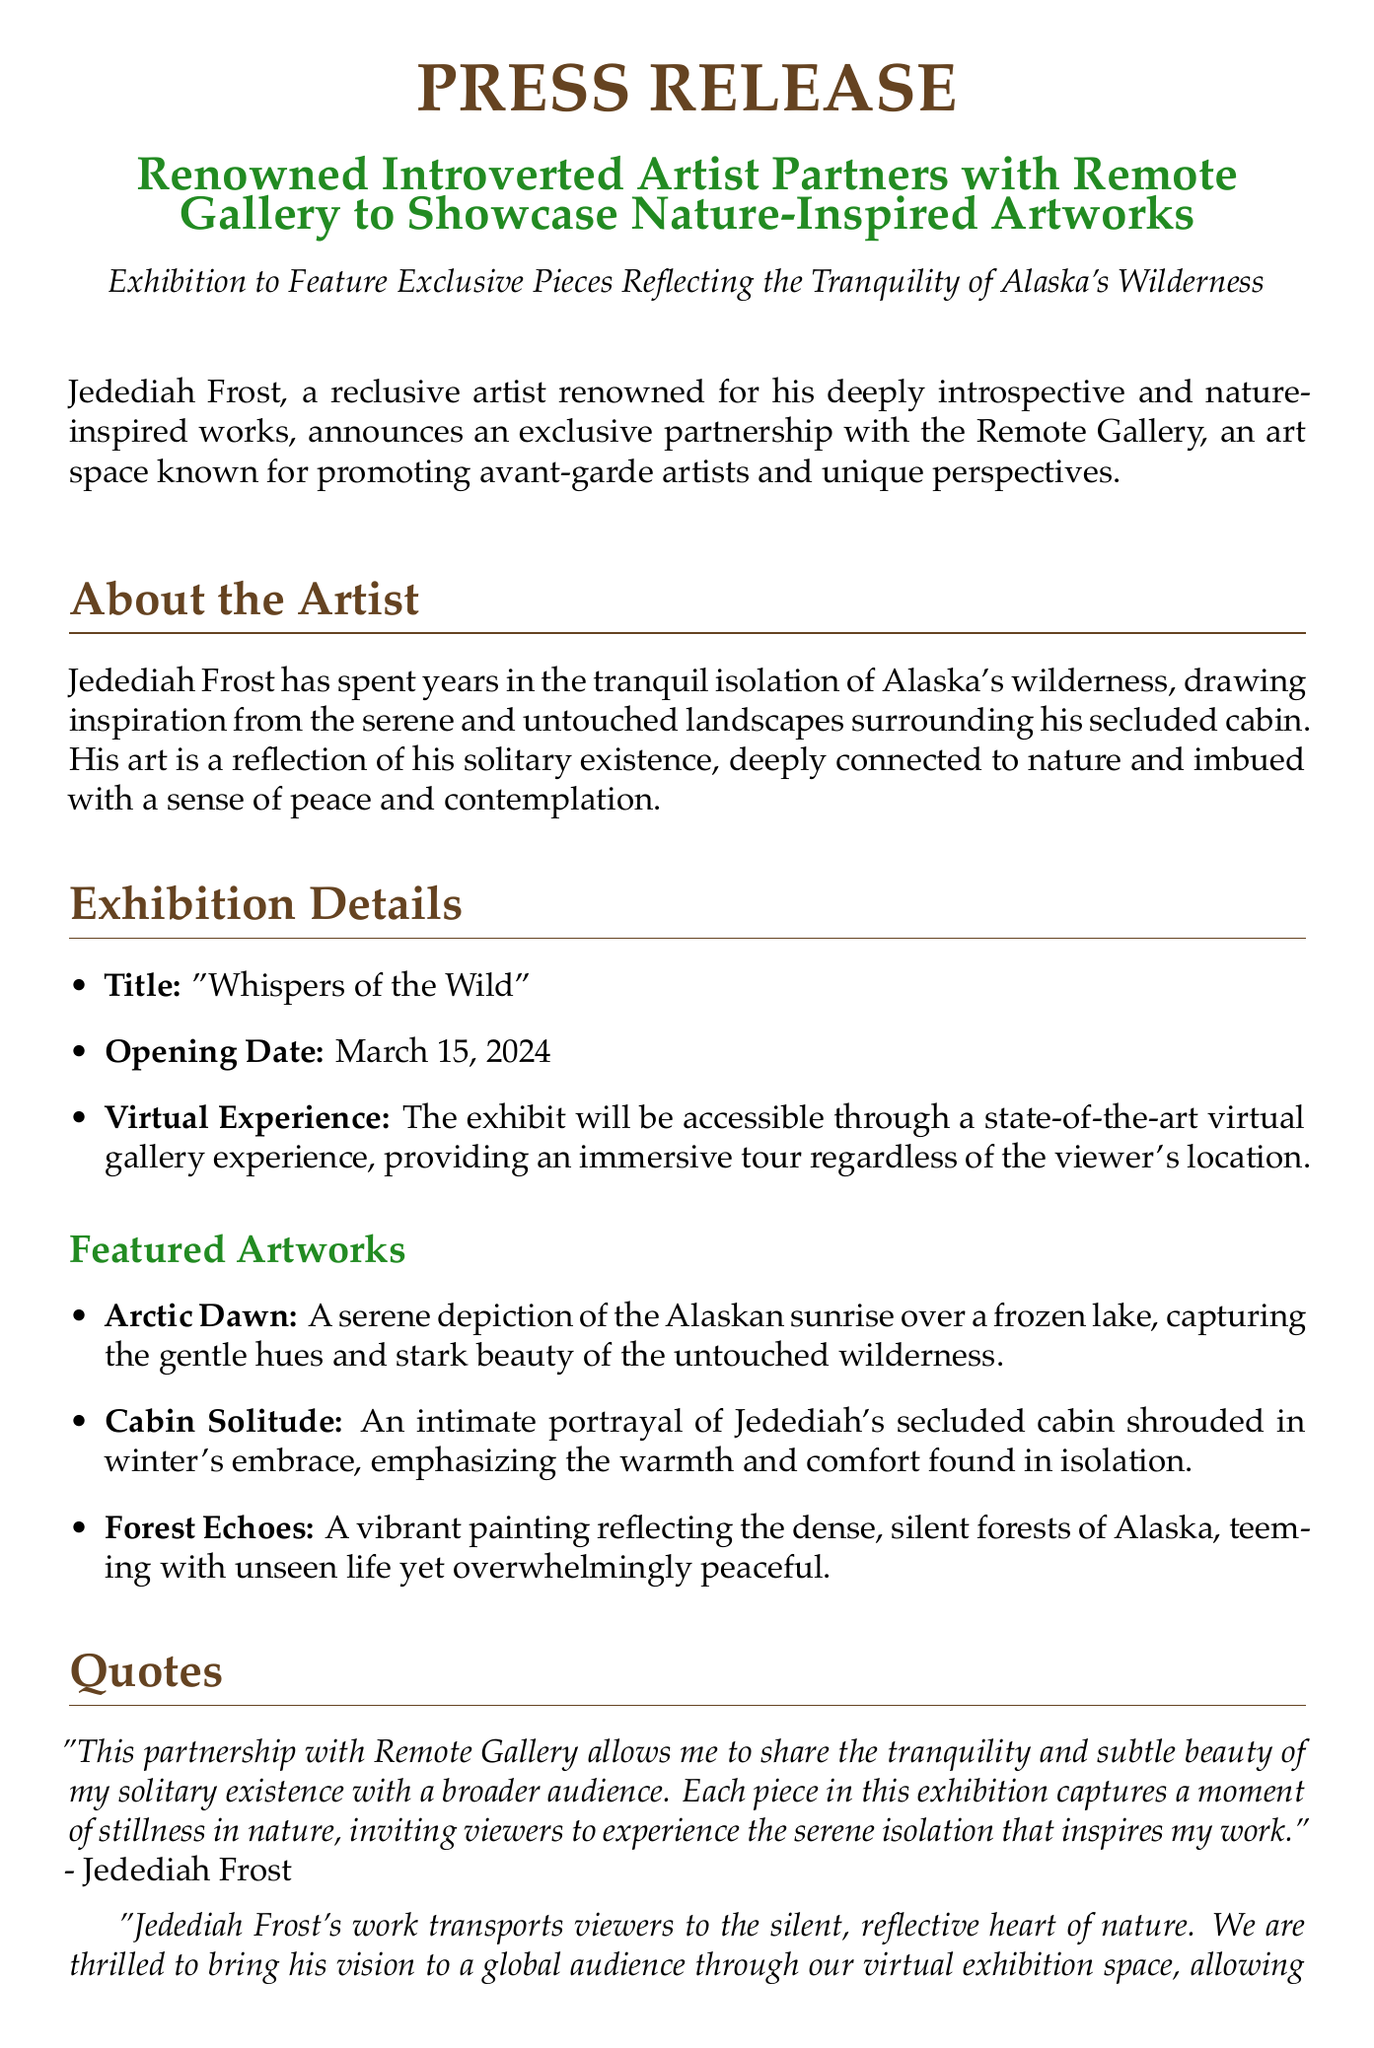What is the title of the exhibition? The title is explicitly mentioned in the exhibition details section of the document.
Answer: "Whispers of the Wild" When is the opening date? The opening date is specified in the exhibition details section of the document.
Answer: March 15, 2024 Who is the artist? The artist's name is introduced in the opening paragraph of the press release.
Answer: Jedediah Frost What is the name of the gallery? The gallery's name is mentioned at the beginning of the document and throughout the text.
Answer: Remote Gallery What type of experience is offered for the exhibition? The document describes the type of experience available in the exhibition details section.
Answer: Virtual Experience What are the featured artworks focusing on? The artworks are described in detail, emphasizing themes of nature and isolation.
Answer: Nature and isolation Who provided a quote about the exhibition? The quotes section names individuals who spoke about the exhibition.
Answer: Elena Monroe How does the artist describe his work? The artist's perspective on his work is included in his quote within the document.
Answer: Tranquility and subtle beauty What does the artist invite viewers to experience? The artist's quote indicates what he wants viewers to feel while experiencing his work.
Answer: Serene isolation 